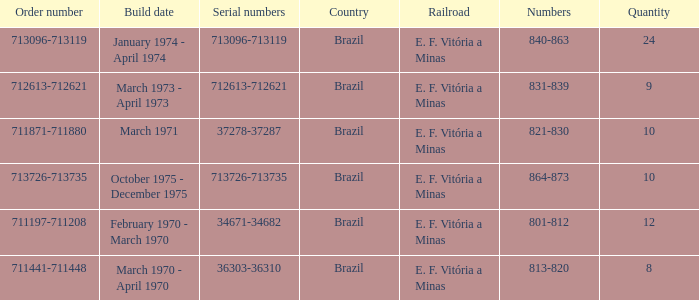How many railroads have the numbers 864-873? 1.0. Parse the table in full. {'header': ['Order number', 'Build date', 'Serial numbers', 'Country', 'Railroad', 'Numbers', 'Quantity'], 'rows': [['713096-713119', 'January 1974 - April 1974', '713096-713119', 'Brazil', 'E. F. Vitória a Minas', '840-863', '24'], ['712613-712621', 'March 1973 - April 1973', '712613-712621', 'Brazil', 'E. F. Vitória a Minas', '831-839', '9'], ['711871-711880', 'March 1971', '37278-37287', 'Brazil', 'E. F. Vitória a Minas', '821-830', '10'], ['713726-713735', 'October 1975 - December 1975', '713726-713735', 'Brazil', 'E. F. Vitória a Minas', '864-873', '10'], ['711197-711208', 'February 1970 - March 1970', '34671-34682', 'Brazil', 'E. F. Vitória a Minas', '801-812', '12'], ['711441-711448', 'March 1970 - April 1970', '36303-36310', 'Brazil', 'E. F. Vitória a Minas', '813-820', '8']]} 